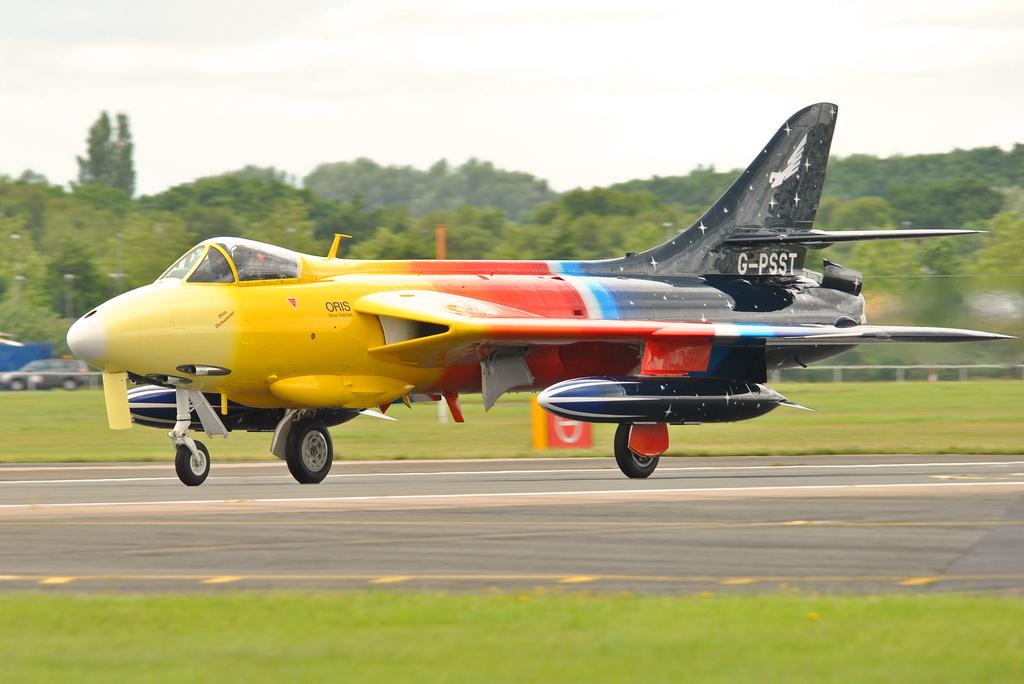What does it say on the tail?
Provide a succinct answer. G-psst. What word is painted on the yellow side of the plane?
Provide a short and direct response. Oris. 